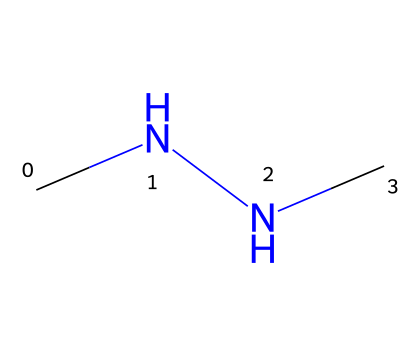What is the molecular formula of monomethylhydrazine? The SMILES representation indicates the presence of one carbon, two nitrogen, and four hydrogen atoms, which corresponds to the molecular formula.
Answer: C2H8N2 How many nitrogen atoms are present in monomethylhydrazine? By analyzing the SMILES, we can see there are two 'N' symbols representing nitrogen atoms.
Answer: 2 What type of chemical is monomethylhydrazine classified as? Monomethylhydrazine, indicated by the presence of hydrazine structure, falls under the category of hydrazines which are known for their use as rocket fuels.
Answer: hydrazine What is the total number of hydrogen atoms in monomethylhydrazine? The SMILES indicates four 'H' symbols related to hydrogen atoms attached to the carbon and nitrogen atoms.
Answer: 8 What kind of bond connects the nitrogen atoms in monomethylhydrazine? The structural representation reveals that the nitrogen atoms are connected by a single bond (as inferred from the SMILES), which is typical for hydrazines.
Answer: single bond What type of reaction is monomethylhydrazine typically used in for propulsion? As a fuel, monomethylhydrazine undergoes a combustion reaction in a rocket engine to produce thrust by generating heated gases.
Answer: combustion 